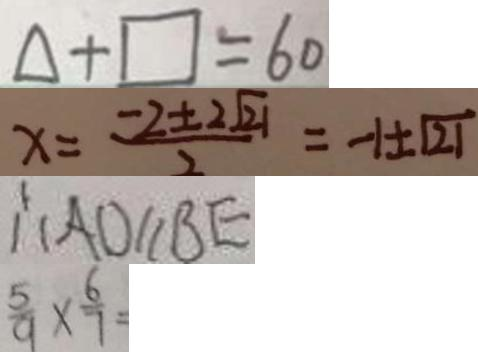Convert formula to latex. <formula><loc_0><loc_0><loc_500><loc_500>\Delta + \square = 6 0 
 x = \frac { - 2 \pm 2 \sqrt { 2 1 } } { 2 } = - 1 \pm \sqrt { 2 1 } 
 \therefore A D / / B E 
 \frac { 5 } { 9 } \times \frac { 6 } { 7 } =</formula> 